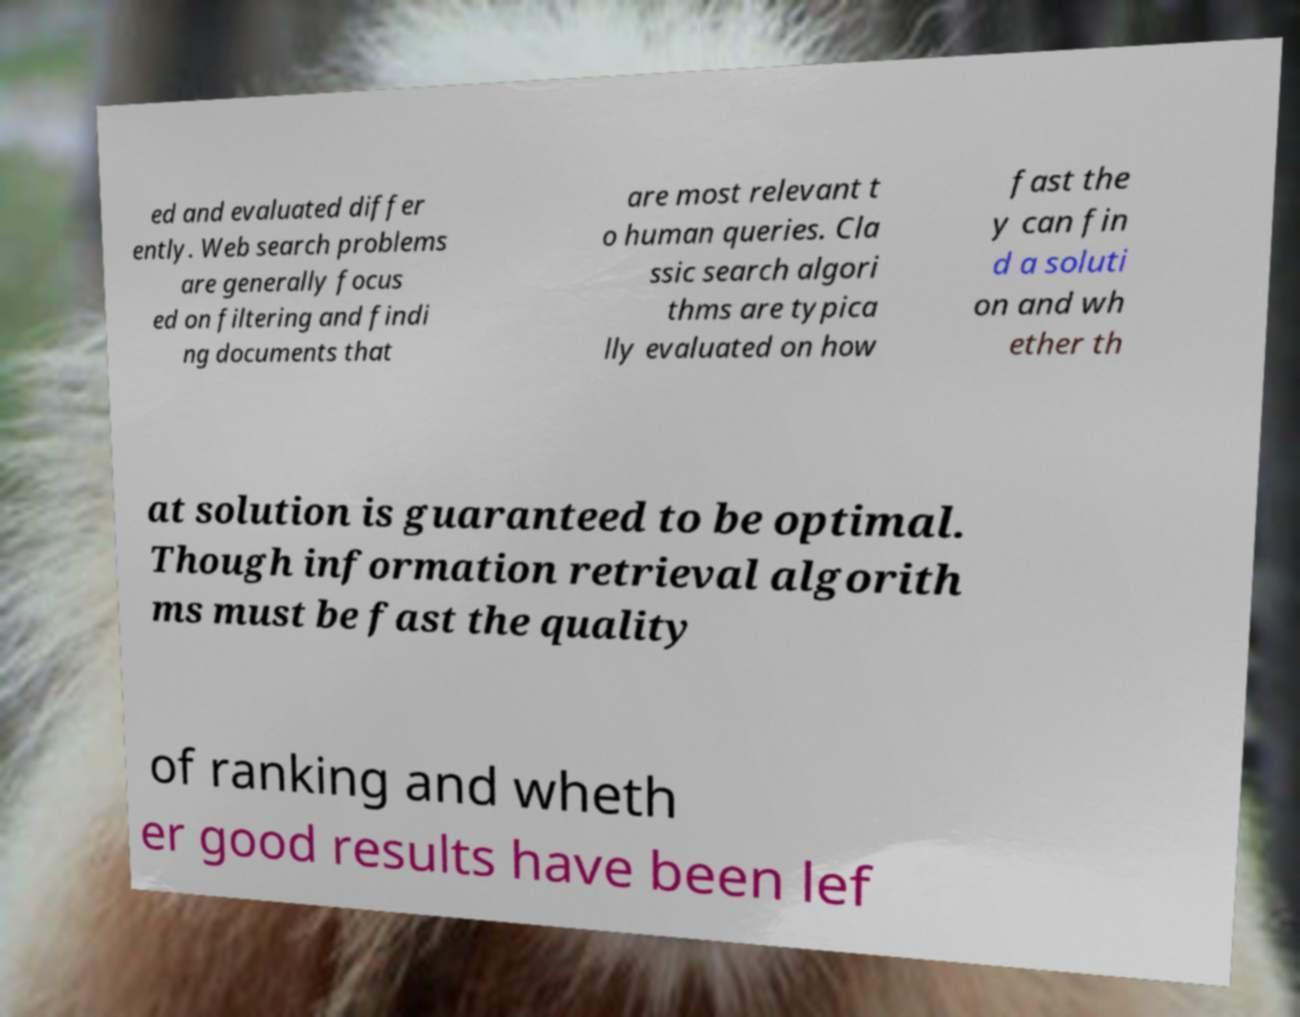Can you accurately transcribe the text from the provided image for me? ed and evaluated differ ently. Web search problems are generally focus ed on filtering and findi ng documents that are most relevant t o human queries. Cla ssic search algori thms are typica lly evaluated on how fast the y can fin d a soluti on and wh ether th at solution is guaranteed to be optimal. Though information retrieval algorith ms must be fast the quality of ranking and wheth er good results have been lef 